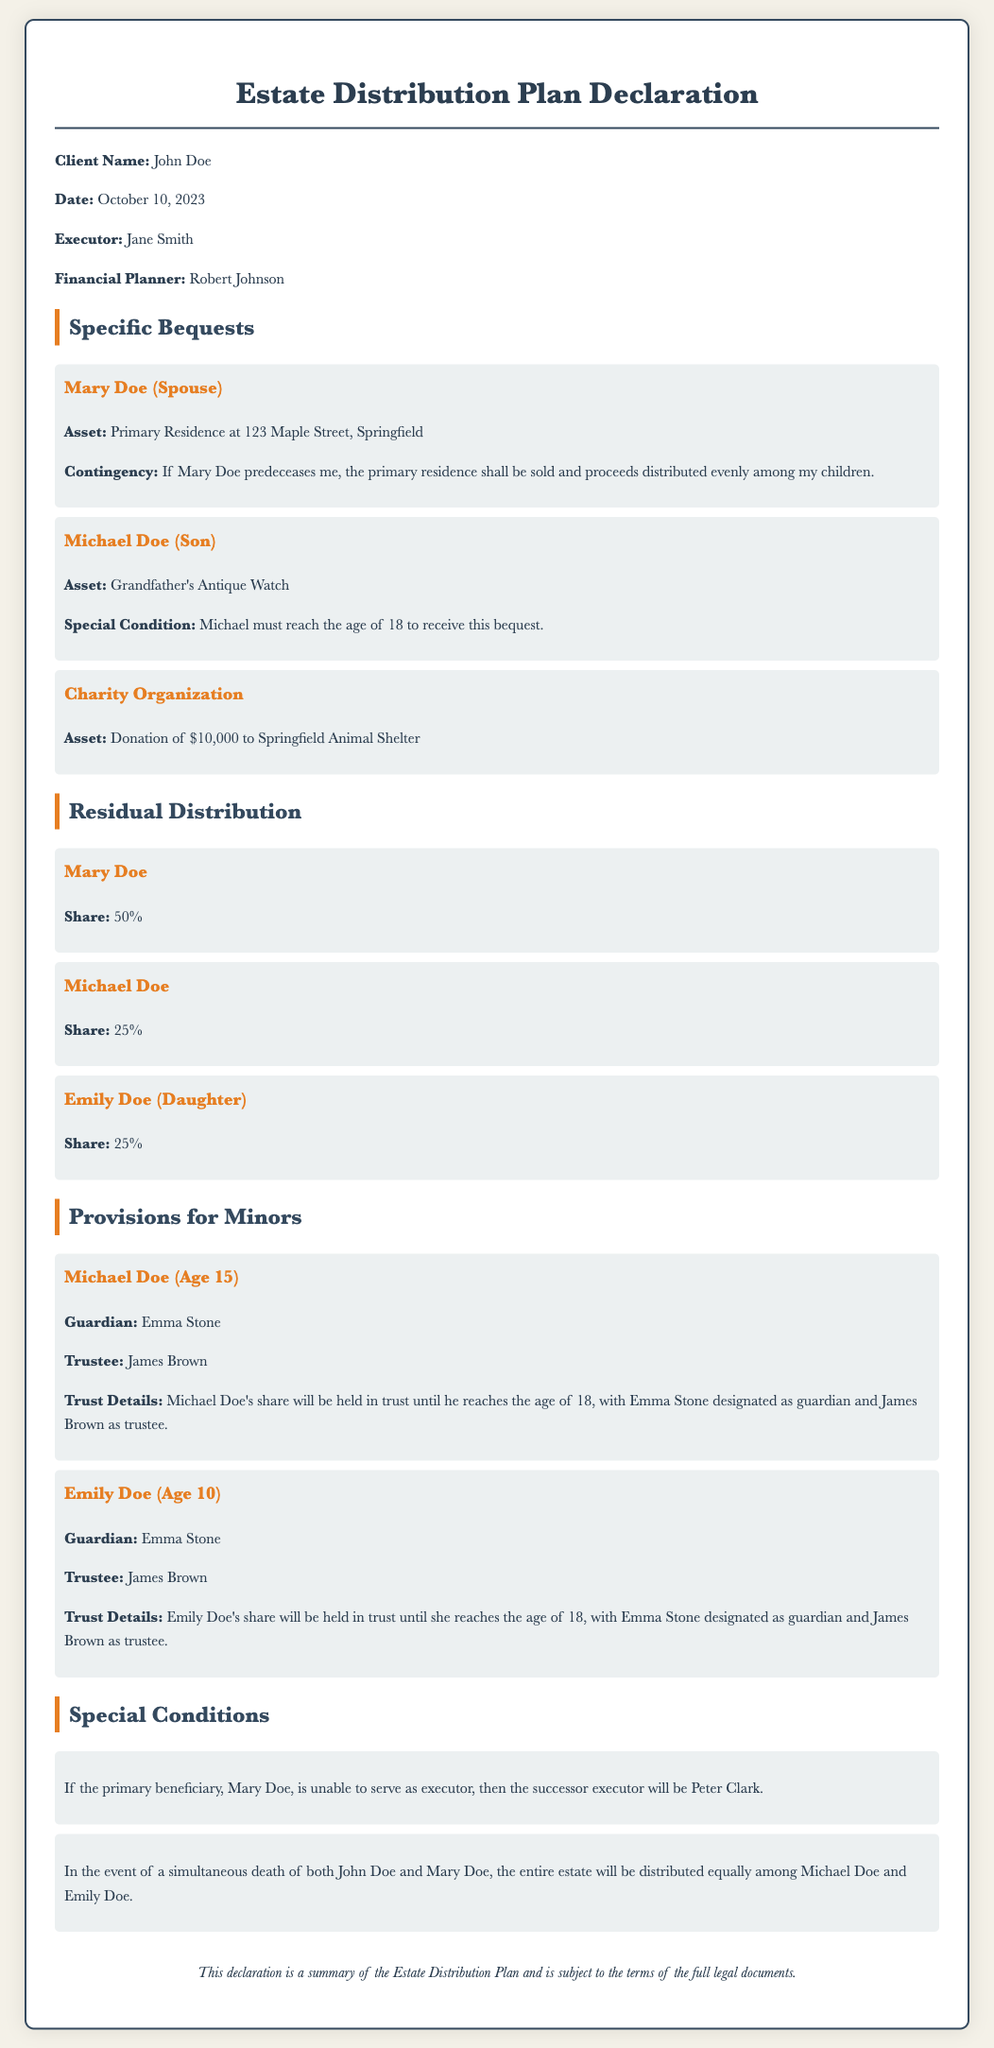What is the client name? The client name is mentioned in the declaration section of the document.
Answer: John Doe Who is the executor? The executor's name is specified in the declaration section of the document.
Answer: Jane Smith What is the age of Emily Doe? Emily Doe's age is provided in the provisions for minors section.
Answer: 10 What percentage of the estate does Michael Doe receive? The percentage allocated to Michael Doe is stated in the residual distribution section.
Answer: 25% If Mary Doe predeceases John Doe, how will the primary residence be distributed? The contingency regarding the primary residence distribution is clearly outlined in the specific bequests section.
Answer: Sold and proceeds distributed evenly among children Who is the guardian for Michael Doe? The guardian's name for Michael Doe is provided in the provisions for minors section.
Answer: Emma Stone What is the donation amount to the Springfield Animal Shelter? The donation amount is mentioned in the specific bequests section.
Answer: $10,000 What happens if both John Doe and Mary Doe die simultaneously? This scenario is stated in the special conditions section of the document.
Answer: Entire estate will be distributed equally among Michael and Emily Doe Who is designated as trustee for the minors? The trustee for the minors is specified in the provisions for minors section.
Answer: James Brown 